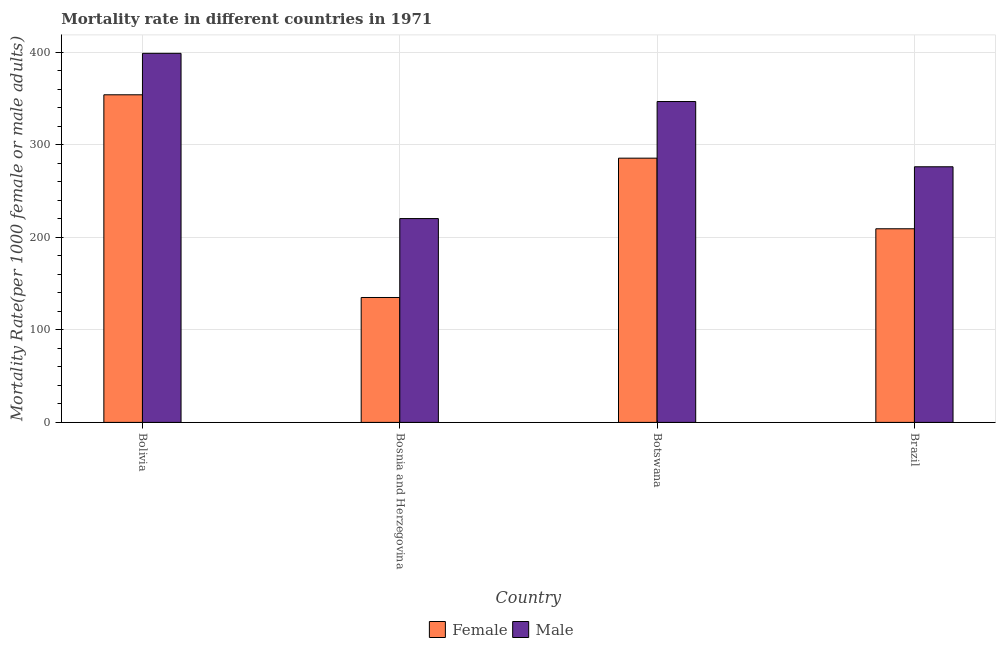How many different coloured bars are there?
Keep it short and to the point. 2. How many groups of bars are there?
Provide a short and direct response. 4. Are the number of bars per tick equal to the number of legend labels?
Provide a short and direct response. Yes. How many bars are there on the 3rd tick from the right?
Your answer should be very brief. 2. What is the label of the 2nd group of bars from the left?
Your answer should be very brief. Bosnia and Herzegovina. In how many cases, is the number of bars for a given country not equal to the number of legend labels?
Offer a very short reply. 0. What is the male mortality rate in Bolivia?
Your answer should be compact. 398.69. Across all countries, what is the maximum female mortality rate?
Your response must be concise. 353.9. Across all countries, what is the minimum female mortality rate?
Ensure brevity in your answer.  134.93. In which country was the male mortality rate maximum?
Your response must be concise. Bolivia. In which country was the male mortality rate minimum?
Ensure brevity in your answer.  Bosnia and Herzegovina. What is the total male mortality rate in the graph?
Offer a terse response. 1241.64. What is the difference between the female mortality rate in Bosnia and Herzegovina and that in Brazil?
Give a very brief answer. -74.23. What is the difference between the female mortality rate in Bolivia and the male mortality rate in Bosnia and Herzegovina?
Make the answer very short. 133.71. What is the average female mortality rate per country?
Offer a very short reply. 245.86. What is the difference between the female mortality rate and male mortality rate in Brazil?
Ensure brevity in your answer.  -66.97. What is the ratio of the male mortality rate in Bolivia to that in Botswana?
Make the answer very short. 1.15. Is the female mortality rate in Bosnia and Herzegovina less than that in Botswana?
Your answer should be very brief. Yes. What is the difference between the highest and the second highest male mortality rate?
Your answer should be compact. 52.06. What is the difference between the highest and the lowest female mortality rate?
Make the answer very short. 218.97. In how many countries, is the female mortality rate greater than the average female mortality rate taken over all countries?
Make the answer very short. 2. Is the sum of the female mortality rate in Botswana and Brazil greater than the maximum male mortality rate across all countries?
Ensure brevity in your answer.  Yes. What does the 1st bar from the right in Botswana represents?
Offer a terse response. Male. How many bars are there?
Your response must be concise. 8. Are the values on the major ticks of Y-axis written in scientific E-notation?
Make the answer very short. No. Does the graph contain any zero values?
Give a very brief answer. No. Does the graph contain grids?
Offer a terse response. Yes. Where does the legend appear in the graph?
Give a very brief answer. Bottom center. How are the legend labels stacked?
Make the answer very short. Horizontal. What is the title of the graph?
Ensure brevity in your answer.  Mortality rate in different countries in 1971. Does "External balance on goods" appear as one of the legend labels in the graph?
Your answer should be compact. No. What is the label or title of the X-axis?
Your answer should be compact. Country. What is the label or title of the Y-axis?
Your response must be concise. Mortality Rate(per 1000 female or male adults). What is the Mortality Rate(per 1000 female or male adults) in Female in Bolivia?
Ensure brevity in your answer.  353.9. What is the Mortality Rate(per 1000 female or male adults) of Male in Bolivia?
Offer a terse response. 398.69. What is the Mortality Rate(per 1000 female or male adults) in Female in Bosnia and Herzegovina?
Provide a succinct answer. 134.93. What is the Mortality Rate(per 1000 female or male adults) of Male in Bosnia and Herzegovina?
Your answer should be very brief. 220.19. What is the Mortality Rate(per 1000 female or male adults) of Female in Botswana?
Provide a short and direct response. 285.44. What is the Mortality Rate(per 1000 female or male adults) in Male in Botswana?
Give a very brief answer. 346.63. What is the Mortality Rate(per 1000 female or male adults) of Female in Brazil?
Your response must be concise. 209.16. What is the Mortality Rate(per 1000 female or male adults) in Male in Brazil?
Provide a short and direct response. 276.13. Across all countries, what is the maximum Mortality Rate(per 1000 female or male adults) of Female?
Your answer should be compact. 353.9. Across all countries, what is the maximum Mortality Rate(per 1000 female or male adults) in Male?
Offer a very short reply. 398.69. Across all countries, what is the minimum Mortality Rate(per 1000 female or male adults) in Female?
Offer a terse response. 134.93. Across all countries, what is the minimum Mortality Rate(per 1000 female or male adults) in Male?
Offer a terse response. 220.19. What is the total Mortality Rate(per 1000 female or male adults) in Female in the graph?
Give a very brief answer. 983.43. What is the total Mortality Rate(per 1000 female or male adults) of Male in the graph?
Make the answer very short. 1241.64. What is the difference between the Mortality Rate(per 1000 female or male adults) in Female in Bolivia and that in Bosnia and Herzegovina?
Ensure brevity in your answer.  218.97. What is the difference between the Mortality Rate(per 1000 female or male adults) in Male in Bolivia and that in Bosnia and Herzegovina?
Keep it short and to the point. 178.5. What is the difference between the Mortality Rate(per 1000 female or male adults) in Female in Bolivia and that in Botswana?
Ensure brevity in your answer.  68.46. What is the difference between the Mortality Rate(per 1000 female or male adults) in Male in Bolivia and that in Botswana?
Offer a terse response. 52.06. What is the difference between the Mortality Rate(per 1000 female or male adults) in Female in Bolivia and that in Brazil?
Provide a succinct answer. 144.74. What is the difference between the Mortality Rate(per 1000 female or male adults) of Male in Bolivia and that in Brazil?
Your answer should be very brief. 122.56. What is the difference between the Mortality Rate(per 1000 female or male adults) in Female in Bosnia and Herzegovina and that in Botswana?
Offer a terse response. -150.51. What is the difference between the Mortality Rate(per 1000 female or male adults) of Male in Bosnia and Herzegovina and that in Botswana?
Your answer should be very brief. -126.44. What is the difference between the Mortality Rate(per 1000 female or male adults) in Female in Bosnia and Herzegovina and that in Brazil?
Your response must be concise. -74.23. What is the difference between the Mortality Rate(per 1000 female or male adults) in Male in Bosnia and Herzegovina and that in Brazil?
Make the answer very short. -55.95. What is the difference between the Mortality Rate(per 1000 female or male adults) of Female in Botswana and that in Brazil?
Provide a succinct answer. 76.28. What is the difference between the Mortality Rate(per 1000 female or male adults) in Male in Botswana and that in Brazil?
Your answer should be very brief. 70.5. What is the difference between the Mortality Rate(per 1000 female or male adults) in Female in Bolivia and the Mortality Rate(per 1000 female or male adults) in Male in Bosnia and Herzegovina?
Offer a very short reply. 133.71. What is the difference between the Mortality Rate(per 1000 female or male adults) of Female in Bolivia and the Mortality Rate(per 1000 female or male adults) of Male in Botswana?
Keep it short and to the point. 7.26. What is the difference between the Mortality Rate(per 1000 female or male adults) in Female in Bolivia and the Mortality Rate(per 1000 female or male adults) in Male in Brazil?
Make the answer very short. 77.76. What is the difference between the Mortality Rate(per 1000 female or male adults) of Female in Bosnia and Herzegovina and the Mortality Rate(per 1000 female or male adults) of Male in Botswana?
Offer a terse response. -211.7. What is the difference between the Mortality Rate(per 1000 female or male adults) of Female in Bosnia and Herzegovina and the Mortality Rate(per 1000 female or male adults) of Male in Brazil?
Offer a very short reply. -141.21. What is the difference between the Mortality Rate(per 1000 female or male adults) of Female in Botswana and the Mortality Rate(per 1000 female or male adults) of Male in Brazil?
Your answer should be compact. 9.3. What is the average Mortality Rate(per 1000 female or male adults) in Female per country?
Your answer should be compact. 245.86. What is the average Mortality Rate(per 1000 female or male adults) in Male per country?
Offer a very short reply. 310.41. What is the difference between the Mortality Rate(per 1000 female or male adults) of Female and Mortality Rate(per 1000 female or male adults) of Male in Bolivia?
Your answer should be compact. -44.79. What is the difference between the Mortality Rate(per 1000 female or male adults) in Female and Mortality Rate(per 1000 female or male adults) in Male in Bosnia and Herzegovina?
Give a very brief answer. -85.26. What is the difference between the Mortality Rate(per 1000 female or male adults) in Female and Mortality Rate(per 1000 female or male adults) in Male in Botswana?
Offer a terse response. -61.19. What is the difference between the Mortality Rate(per 1000 female or male adults) in Female and Mortality Rate(per 1000 female or male adults) in Male in Brazil?
Offer a terse response. -66.97. What is the ratio of the Mortality Rate(per 1000 female or male adults) in Female in Bolivia to that in Bosnia and Herzegovina?
Your answer should be very brief. 2.62. What is the ratio of the Mortality Rate(per 1000 female or male adults) of Male in Bolivia to that in Bosnia and Herzegovina?
Your answer should be compact. 1.81. What is the ratio of the Mortality Rate(per 1000 female or male adults) of Female in Bolivia to that in Botswana?
Keep it short and to the point. 1.24. What is the ratio of the Mortality Rate(per 1000 female or male adults) in Male in Bolivia to that in Botswana?
Offer a very short reply. 1.15. What is the ratio of the Mortality Rate(per 1000 female or male adults) of Female in Bolivia to that in Brazil?
Your answer should be very brief. 1.69. What is the ratio of the Mortality Rate(per 1000 female or male adults) in Male in Bolivia to that in Brazil?
Your response must be concise. 1.44. What is the ratio of the Mortality Rate(per 1000 female or male adults) of Female in Bosnia and Herzegovina to that in Botswana?
Make the answer very short. 0.47. What is the ratio of the Mortality Rate(per 1000 female or male adults) in Male in Bosnia and Herzegovina to that in Botswana?
Offer a terse response. 0.64. What is the ratio of the Mortality Rate(per 1000 female or male adults) of Female in Bosnia and Herzegovina to that in Brazil?
Offer a terse response. 0.65. What is the ratio of the Mortality Rate(per 1000 female or male adults) of Male in Bosnia and Herzegovina to that in Brazil?
Offer a terse response. 0.8. What is the ratio of the Mortality Rate(per 1000 female or male adults) of Female in Botswana to that in Brazil?
Offer a terse response. 1.36. What is the ratio of the Mortality Rate(per 1000 female or male adults) in Male in Botswana to that in Brazil?
Offer a very short reply. 1.26. What is the difference between the highest and the second highest Mortality Rate(per 1000 female or male adults) in Female?
Offer a very short reply. 68.46. What is the difference between the highest and the second highest Mortality Rate(per 1000 female or male adults) in Male?
Your answer should be very brief. 52.06. What is the difference between the highest and the lowest Mortality Rate(per 1000 female or male adults) of Female?
Provide a succinct answer. 218.97. What is the difference between the highest and the lowest Mortality Rate(per 1000 female or male adults) in Male?
Keep it short and to the point. 178.5. 